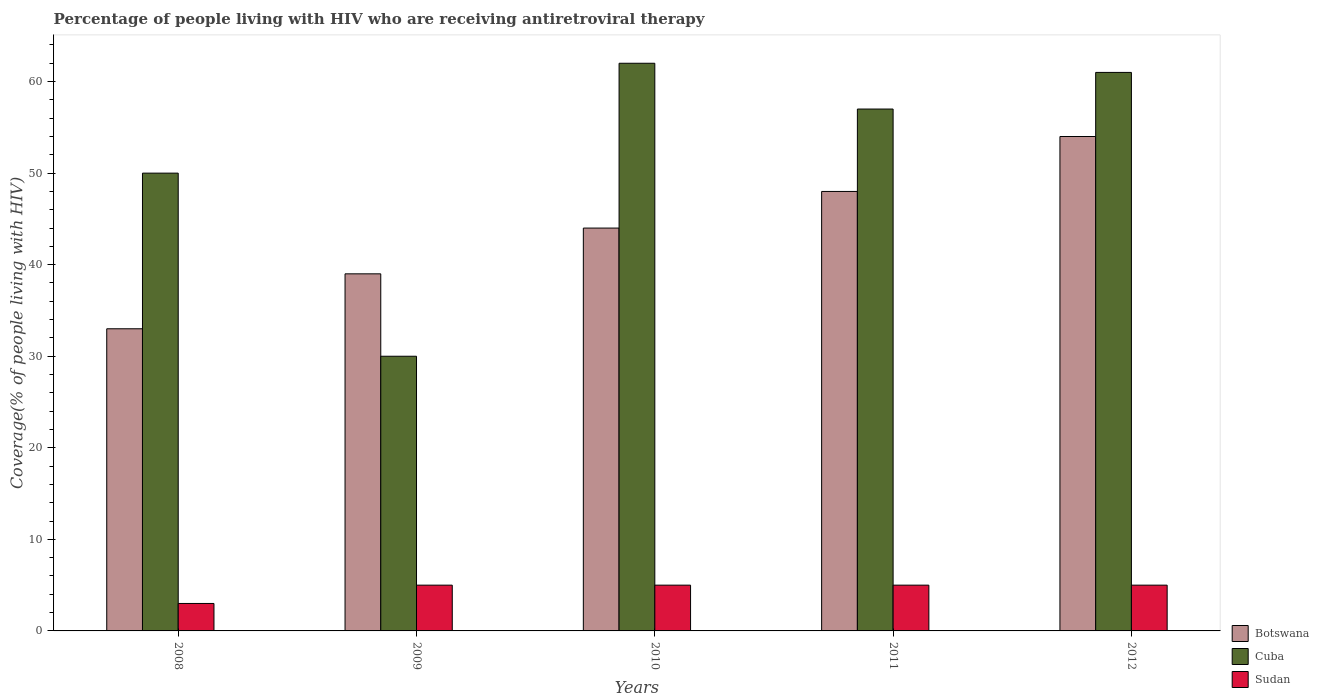How many groups of bars are there?
Ensure brevity in your answer.  5. Are the number of bars per tick equal to the number of legend labels?
Provide a short and direct response. Yes. How many bars are there on the 3rd tick from the left?
Give a very brief answer. 3. What is the percentage of the HIV infected people who are receiving antiretroviral therapy in Sudan in 2011?
Provide a succinct answer. 5. Across all years, what is the maximum percentage of the HIV infected people who are receiving antiretroviral therapy in Cuba?
Provide a succinct answer. 62. Across all years, what is the minimum percentage of the HIV infected people who are receiving antiretroviral therapy in Cuba?
Keep it short and to the point. 30. What is the total percentage of the HIV infected people who are receiving antiretroviral therapy in Cuba in the graph?
Ensure brevity in your answer.  260. What is the difference between the percentage of the HIV infected people who are receiving antiretroviral therapy in Cuba in 2008 and that in 2011?
Offer a very short reply. -7. What is the difference between the percentage of the HIV infected people who are receiving antiretroviral therapy in Sudan in 2011 and the percentage of the HIV infected people who are receiving antiretroviral therapy in Botswana in 2008?
Keep it short and to the point. -28. What is the average percentage of the HIV infected people who are receiving antiretroviral therapy in Botswana per year?
Provide a short and direct response. 43.6. In the year 2009, what is the difference between the percentage of the HIV infected people who are receiving antiretroviral therapy in Sudan and percentage of the HIV infected people who are receiving antiretroviral therapy in Botswana?
Offer a terse response. -34. What is the ratio of the percentage of the HIV infected people who are receiving antiretroviral therapy in Botswana in 2009 to that in 2011?
Make the answer very short. 0.81. Is the percentage of the HIV infected people who are receiving antiretroviral therapy in Sudan in 2011 less than that in 2012?
Offer a terse response. No. What is the difference between the highest and the second highest percentage of the HIV infected people who are receiving antiretroviral therapy in Cuba?
Offer a terse response. 1. What is the difference between the highest and the lowest percentage of the HIV infected people who are receiving antiretroviral therapy in Botswana?
Make the answer very short. 21. In how many years, is the percentage of the HIV infected people who are receiving antiretroviral therapy in Cuba greater than the average percentage of the HIV infected people who are receiving antiretroviral therapy in Cuba taken over all years?
Keep it short and to the point. 3. What does the 2nd bar from the left in 2009 represents?
Your response must be concise. Cuba. What does the 1st bar from the right in 2012 represents?
Your answer should be compact. Sudan. Is it the case that in every year, the sum of the percentage of the HIV infected people who are receiving antiretroviral therapy in Sudan and percentage of the HIV infected people who are receiving antiretroviral therapy in Botswana is greater than the percentage of the HIV infected people who are receiving antiretroviral therapy in Cuba?
Make the answer very short. No. How many bars are there?
Offer a very short reply. 15. Are all the bars in the graph horizontal?
Keep it short and to the point. No. How many years are there in the graph?
Give a very brief answer. 5. Are the values on the major ticks of Y-axis written in scientific E-notation?
Provide a short and direct response. No. Does the graph contain any zero values?
Your response must be concise. No. Where does the legend appear in the graph?
Make the answer very short. Bottom right. What is the title of the graph?
Ensure brevity in your answer.  Percentage of people living with HIV who are receiving antiretroviral therapy. What is the label or title of the Y-axis?
Your response must be concise. Coverage(% of people living with HIV). What is the Coverage(% of people living with HIV) of Botswana in 2008?
Give a very brief answer. 33. What is the Coverage(% of people living with HIV) of Sudan in 2008?
Your answer should be compact. 3. What is the Coverage(% of people living with HIV) in Botswana in 2009?
Your answer should be very brief. 39. What is the Coverage(% of people living with HIV) in Sudan in 2009?
Keep it short and to the point. 5. What is the Coverage(% of people living with HIV) of Botswana in 2010?
Give a very brief answer. 44. What is the Coverage(% of people living with HIV) of Cuba in 2010?
Provide a short and direct response. 62. What is the Coverage(% of people living with HIV) of Botswana in 2011?
Ensure brevity in your answer.  48. What is the Coverage(% of people living with HIV) in Cuba in 2011?
Keep it short and to the point. 57. What is the Coverage(% of people living with HIV) of Sudan in 2011?
Your answer should be very brief. 5. What is the Coverage(% of people living with HIV) of Sudan in 2012?
Ensure brevity in your answer.  5. Across all years, what is the maximum Coverage(% of people living with HIV) in Cuba?
Give a very brief answer. 62. Across all years, what is the maximum Coverage(% of people living with HIV) of Sudan?
Your answer should be compact. 5. Across all years, what is the minimum Coverage(% of people living with HIV) of Sudan?
Provide a short and direct response. 3. What is the total Coverage(% of people living with HIV) in Botswana in the graph?
Give a very brief answer. 218. What is the total Coverage(% of people living with HIV) of Cuba in the graph?
Your answer should be very brief. 260. What is the difference between the Coverage(% of people living with HIV) of Cuba in 2008 and that in 2009?
Your answer should be very brief. 20. What is the difference between the Coverage(% of people living with HIV) of Sudan in 2008 and that in 2009?
Make the answer very short. -2. What is the difference between the Coverage(% of people living with HIV) in Botswana in 2008 and that in 2010?
Offer a very short reply. -11. What is the difference between the Coverage(% of people living with HIV) of Cuba in 2008 and that in 2010?
Ensure brevity in your answer.  -12. What is the difference between the Coverage(% of people living with HIV) of Sudan in 2008 and that in 2010?
Provide a short and direct response. -2. What is the difference between the Coverage(% of people living with HIV) of Cuba in 2008 and that in 2011?
Give a very brief answer. -7. What is the difference between the Coverage(% of people living with HIV) in Sudan in 2008 and that in 2011?
Your answer should be very brief. -2. What is the difference between the Coverage(% of people living with HIV) in Cuba in 2008 and that in 2012?
Your answer should be compact. -11. What is the difference between the Coverage(% of people living with HIV) in Cuba in 2009 and that in 2010?
Your answer should be compact. -32. What is the difference between the Coverage(% of people living with HIV) of Sudan in 2009 and that in 2011?
Give a very brief answer. 0. What is the difference between the Coverage(% of people living with HIV) of Cuba in 2009 and that in 2012?
Your answer should be compact. -31. What is the difference between the Coverage(% of people living with HIV) in Botswana in 2010 and that in 2011?
Provide a short and direct response. -4. What is the difference between the Coverage(% of people living with HIV) in Cuba in 2010 and that in 2011?
Your answer should be very brief. 5. What is the difference between the Coverage(% of people living with HIV) of Sudan in 2010 and that in 2011?
Ensure brevity in your answer.  0. What is the difference between the Coverage(% of people living with HIV) of Botswana in 2010 and that in 2012?
Your answer should be compact. -10. What is the difference between the Coverage(% of people living with HIV) of Sudan in 2010 and that in 2012?
Offer a terse response. 0. What is the difference between the Coverage(% of people living with HIV) of Botswana in 2011 and that in 2012?
Offer a terse response. -6. What is the difference between the Coverage(% of people living with HIV) in Cuba in 2011 and that in 2012?
Give a very brief answer. -4. What is the difference between the Coverage(% of people living with HIV) in Sudan in 2011 and that in 2012?
Make the answer very short. 0. What is the difference between the Coverage(% of people living with HIV) in Botswana in 2008 and the Coverage(% of people living with HIV) in Cuba in 2009?
Give a very brief answer. 3. What is the difference between the Coverage(% of people living with HIV) in Cuba in 2008 and the Coverage(% of people living with HIV) in Sudan in 2009?
Provide a short and direct response. 45. What is the difference between the Coverage(% of people living with HIV) in Botswana in 2008 and the Coverage(% of people living with HIV) in Sudan in 2011?
Your answer should be compact. 28. What is the difference between the Coverage(% of people living with HIV) in Botswana in 2008 and the Coverage(% of people living with HIV) in Sudan in 2012?
Give a very brief answer. 28. What is the difference between the Coverage(% of people living with HIV) in Cuba in 2008 and the Coverage(% of people living with HIV) in Sudan in 2012?
Offer a terse response. 45. What is the difference between the Coverage(% of people living with HIV) of Botswana in 2009 and the Coverage(% of people living with HIV) of Sudan in 2010?
Offer a terse response. 34. What is the difference between the Coverage(% of people living with HIV) of Botswana in 2009 and the Coverage(% of people living with HIV) of Cuba in 2011?
Make the answer very short. -18. What is the difference between the Coverage(% of people living with HIV) of Botswana in 2009 and the Coverage(% of people living with HIV) of Sudan in 2011?
Offer a very short reply. 34. What is the difference between the Coverage(% of people living with HIV) in Botswana in 2009 and the Coverage(% of people living with HIV) in Sudan in 2012?
Offer a very short reply. 34. What is the difference between the Coverage(% of people living with HIV) of Botswana in 2010 and the Coverage(% of people living with HIV) of Sudan in 2011?
Your answer should be very brief. 39. What is the difference between the Coverage(% of people living with HIV) of Botswana in 2010 and the Coverage(% of people living with HIV) of Sudan in 2012?
Your answer should be compact. 39. What is the difference between the Coverage(% of people living with HIV) in Cuba in 2010 and the Coverage(% of people living with HIV) in Sudan in 2012?
Offer a very short reply. 57. What is the average Coverage(% of people living with HIV) of Botswana per year?
Provide a short and direct response. 43.6. What is the average Coverage(% of people living with HIV) in Cuba per year?
Your answer should be very brief. 52. In the year 2009, what is the difference between the Coverage(% of people living with HIV) in Botswana and Coverage(% of people living with HIV) in Cuba?
Offer a terse response. 9. In the year 2009, what is the difference between the Coverage(% of people living with HIV) of Botswana and Coverage(% of people living with HIV) of Sudan?
Ensure brevity in your answer.  34. In the year 2009, what is the difference between the Coverage(% of people living with HIV) of Cuba and Coverage(% of people living with HIV) of Sudan?
Provide a succinct answer. 25. In the year 2010, what is the difference between the Coverage(% of people living with HIV) of Botswana and Coverage(% of people living with HIV) of Sudan?
Give a very brief answer. 39. In the year 2010, what is the difference between the Coverage(% of people living with HIV) in Cuba and Coverage(% of people living with HIV) in Sudan?
Make the answer very short. 57. In the year 2011, what is the difference between the Coverage(% of people living with HIV) in Cuba and Coverage(% of people living with HIV) in Sudan?
Make the answer very short. 52. In the year 2012, what is the difference between the Coverage(% of people living with HIV) in Botswana and Coverage(% of people living with HIV) in Sudan?
Offer a very short reply. 49. What is the ratio of the Coverage(% of people living with HIV) of Botswana in 2008 to that in 2009?
Offer a very short reply. 0.85. What is the ratio of the Coverage(% of people living with HIV) of Botswana in 2008 to that in 2010?
Give a very brief answer. 0.75. What is the ratio of the Coverage(% of people living with HIV) in Cuba in 2008 to that in 2010?
Your answer should be very brief. 0.81. What is the ratio of the Coverage(% of people living with HIV) in Sudan in 2008 to that in 2010?
Ensure brevity in your answer.  0.6. What is the ratio of the Coverage(% of people living with HIV) of Botswana in 2008 to that in 2011?
Keep it short and to the point. 0.69. What is the ratio of the Coverage(% of people living with HIV) in Cuba in 2008 to that in 2011?
Ensure brevity in your answer.  0.88. What is the ratio of the Coverage(% of people living with HIV) of Sudan in 2008 to that in 2011?
Your answer should be compact. 0.6. What is the ratio of the Coverage(% of people living with HIV) of Botswana in 2008 to that in 2012?
Provide a succinct answer. 0.61. What is the ratio of the Coverage(% of people living with HIV) of Cuba in 2008 to that in 2012?
Your answer should be very brief. 0.82. What is the ratio of the Coverage(% of people living with HIV) in Sudan in 2008 to that in 2012?
Offer a terse response. 0.6. What is the ratio of the Coverage(% of people living with HIV) in Botswana in 2009 to that in 2010?
Your response must be concise. 0.89. What is the ratio of the Coverage(% of people living with HIV) in Cuba in 2009 to that in 2010?
Your response must be concise. 0.48. What is the ratio of the Coverage(% of people living with HIV) in Sudan in 2009 to that in 2010?
Keep it short and to the point. 1. What is the ratio of the Coverage(% of people living with HIV) in Botswana in 2009 to that in 2011?
Offer a terse response. 0.81. What is the ratio of the Coverage(% of people living with HIV) in Cuba in 2009 to that in 2011?
Your response must be concise. 0.53. What is the ratio of the Coverage(% of people living with HIV) in Sudan in 2009 to that in 2011?
Make the answer very short. 1. What is the ratio of the Coverage(% of people living with HIV) of Botswana in 2009 to that in 2012?
Ensure brevity in your answer.  0.72. What is the ratio of the Coverage(% of people living with HIV) of Cuba in 2009 to that in 2012?
Provide a short and direct response. 0.49. What is the ratio of the Coverage(% of people living with HIV) in Sudan in 2009 to that in 2012?
Your answer should be compact. 1. What is the ratio of the Coverage(% of people living with HIV) in Botswana in 2010 to that in 2011?
Ensure brevity in your answer.  0.92. What is the ratio of the Coverage(% of people living with HIV) in Cuba in 2010 to that in 2011?
Your answer should be very brief. 1.09. What is the ratio of the Coverage(% of people living with HIV) of Sudan in 2010 to that in 2011?
Keep it short and to the point. 1. What is the ratio of the Coverage(% of people living with HIV) in Botswana in 2010 to that in 2012?
Your answer should be very brief. 0.81. What is the ratio of the Coverage(% of people living with HIV) in Cuba in 2010 to that in 2012?
Offer a terse response. 1.02. What is the ratio of the Coverage(% of people living with HIV) in Cuba in 2011 to that in 2012?
Make the answer very short. 0.93. What is the ratio of the Coverage(% of people living with HIV) in Sudan in 2011 to that in 2012?
Give a very brief answer. 1. What is the difference between the highest and the lowest Coverage(% of people living with HIV) of Cuba?
Keep it short and to the point. 32. 